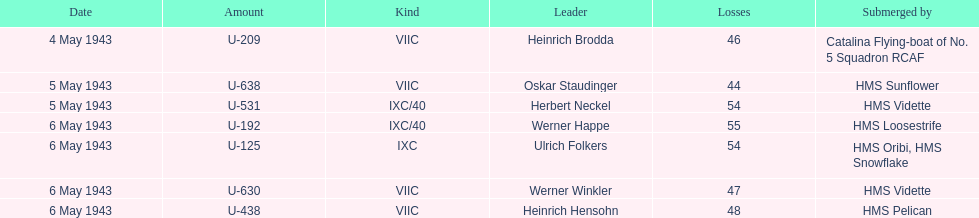How many captains are listed? 7. 